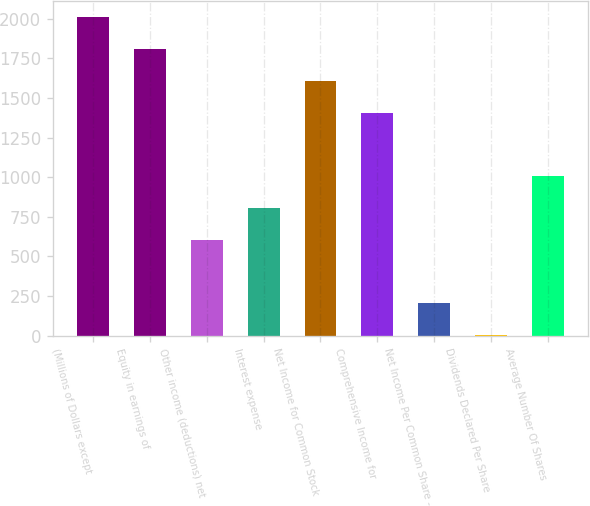<chart> <loc_0><loc_0><loc_500><loc_500><bar_chart><fcel>(Millions of Dollars except<fcel>Equity in earnings of<fcel>Other income (deductions) net<fcel>Interest expense<fcel>Net Income for Common Stock<fcel>Comprehensive Income for<fcel>Net Income Per Common Share -<fcel>Dividends Declared Per Share<fcel>Average Number Of Shares<nl><fcel>2011<fcel>1810.14<fcel>604.98<fcel>805.84<fcel>1609.28<fcel>1408.42<fcel>203.26<fcel>2.4<fcel>1006.7<nl></chart> 